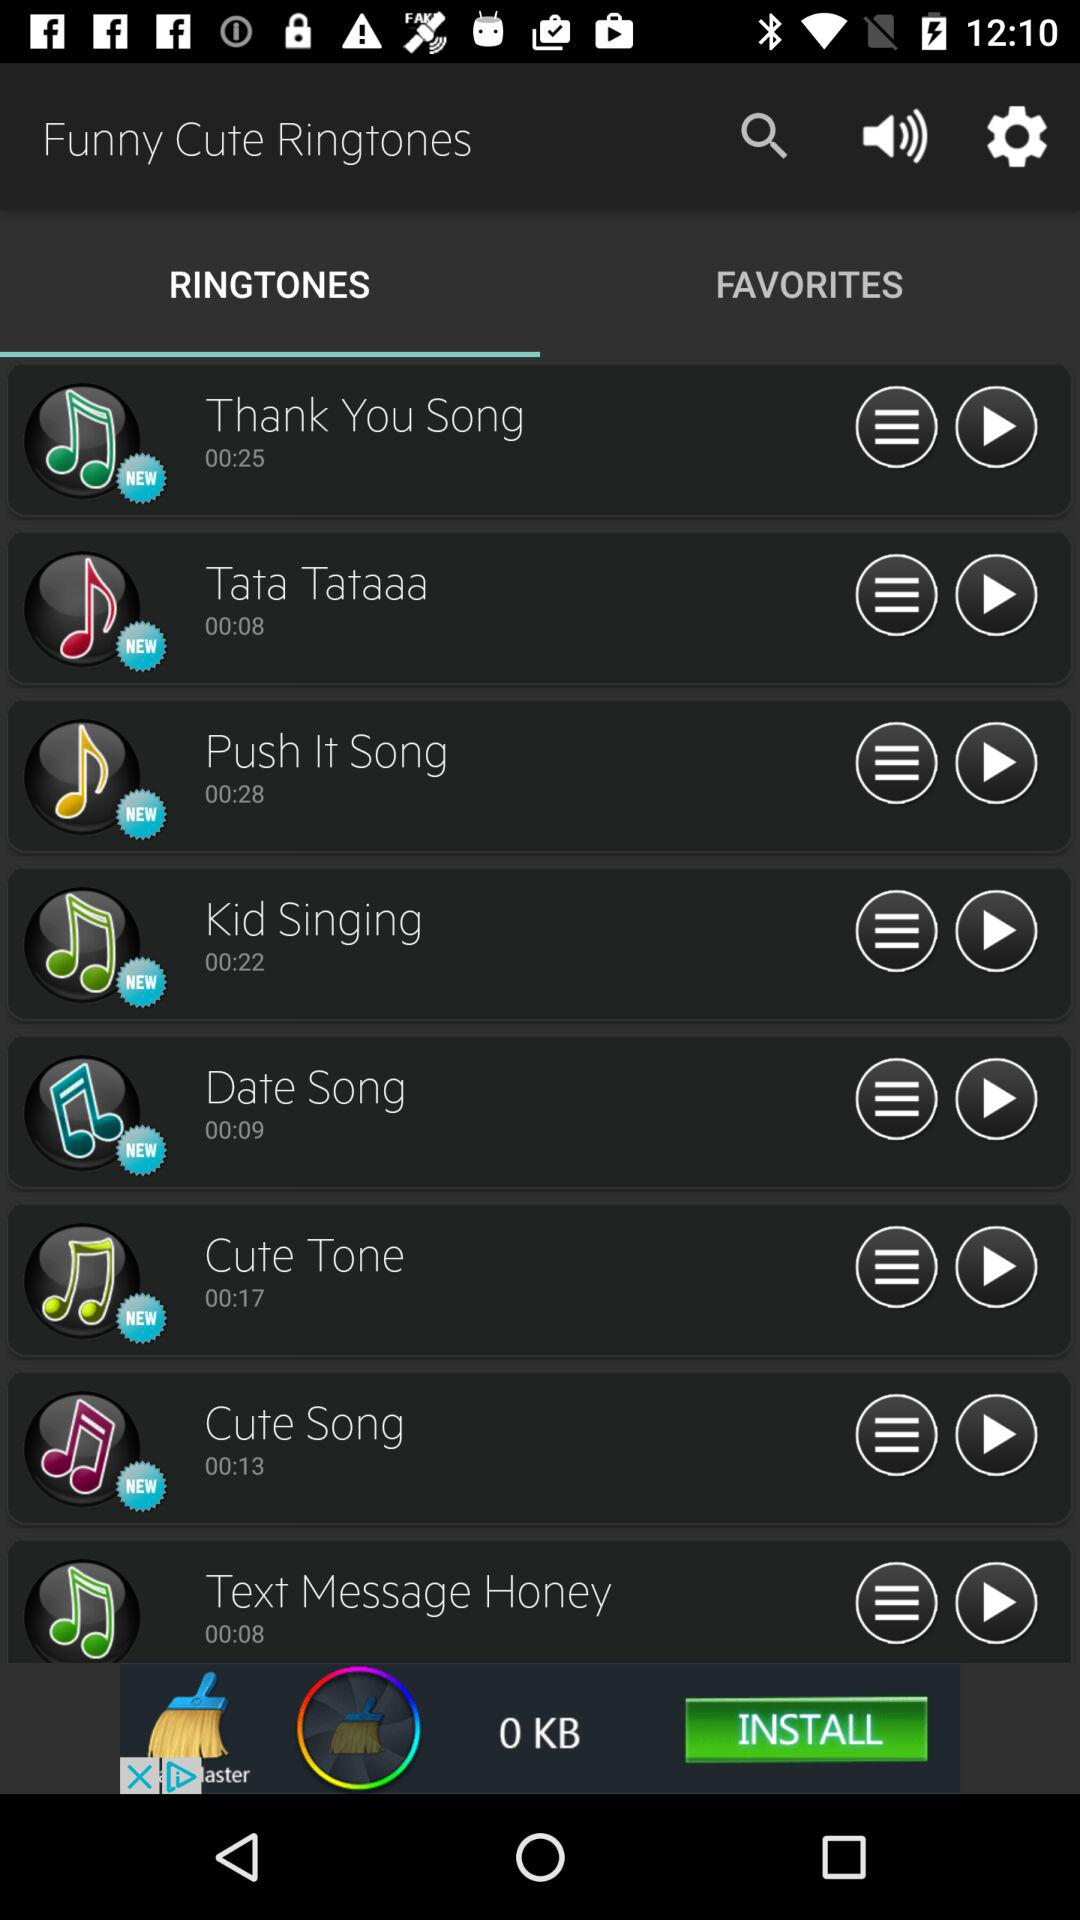What is the duration of the "Thank You Song" ringtone? The duration of the "Thank You Song" ringtone is 25 seconds. 